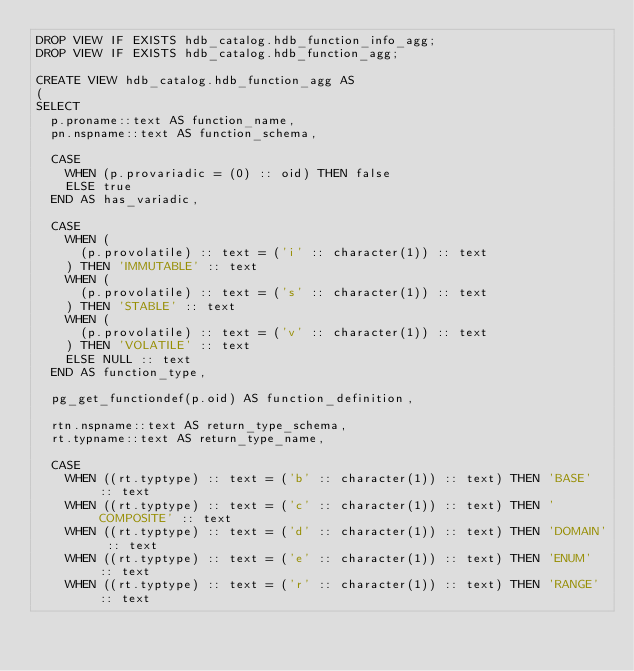<code> <loc_0><loc_0><loc_500><loc_500><_SQL_>DROP VIEW IF EXISTS hdb_catalog.hdb_function_info_agg;
DROP VIEW IF EXISTS hdb_catalog.hdb_function_agg;

CREATE VIEW hdb_catalog.hdb_function_agg AS
(
SELECT
  p.proname::text AS function_name,
  pn.nspname::text AS function_schema,

  CASE
    WHEN (p.provariadic = (0) :: oid) THEN false
    ELSE true
  END AS has_variadic,

  CASE
    WHEN (
      (p.provolatile) :: text = ('i' :: character(1)) :: text
    ) THEN 'IMMUTABLE' :: text
    WHEN (
      (p.provolatile) :: text = ('s' :: character(1)) :: text
    ) THEN 'STABLE' :: text
    WHEN (
      (p.provolatile) :: text = ('v' :: character(1)) :: text
    ) THEN 'VOLATILE' :: text
    ELSE NULL :: text
  END AS function_type,

  pg_get_functiondef(p.oid) AS function_definition,

  rtn.nspname::text AS return_type_schema,
  rt.typname::text AS return_type_name,

  CASE
    WHEN ((rt.typtype) :: text = ('b' :: character(1)) :: text) THEN 'BASE' :: text
    WHEN ((rt.typtype) :: text = ('c' :: character(1)) :: text) THEN 'COMPOSITE' :: text
    WHEN ((rt.typtype) :: text = ('d' :: character(1)) :: text) THEN 'DOMAIN' :: text
    WHEN ((rt.typtype) :: text = ('e' :: character(1)) :: text) THEN 'ENUM' :: text
    WHEN ((rt.typtype) :: text = ('r' :: character(1)) :: text) THEN 'RANGE' :: text</code> 